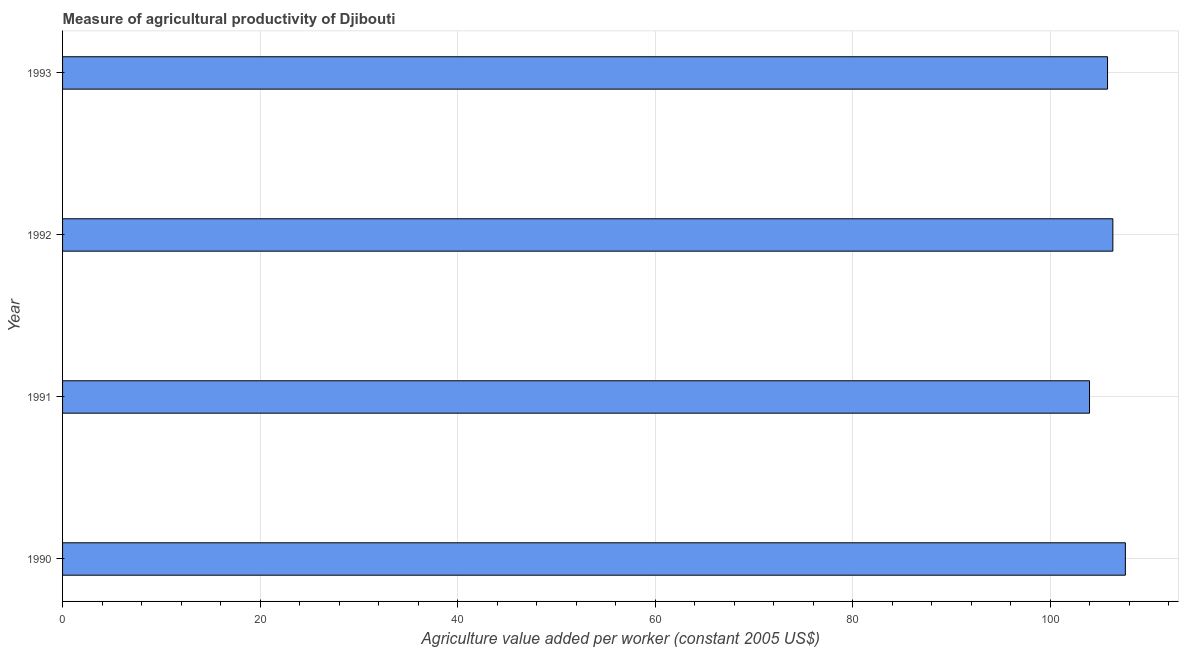Does the graph contain grids?
Your answer should be very brief. Yes. What is the title of the graph?
Offer a terse response. Measure of agricultural productivity of Djibouti. What is the label or title of the X-axis?
Provide a short and direct response. Agriculture value added per worker (constant 2005 US$). What is the label or title of the Y-axis?
Provide a short and direct response. Year. What is the agriculture value added per worker in 1990?
Your response must be concise. 107.61. Across all years, what is the maximum agriculture value added per worker?
Provide a short and direct response. 107.61. Across all years, what is the minimum agriculture value added per worker?
Provide a short and direct response. 103.98. What is the sum of the agriculture value added per worker?
Ensure brevity in your answer.  423.75. What is the difference between the agriculture value added per worker in 1990 and 1992?
Your answer should be compact. 1.26. What is the average agriculture value added per worker per year?
Your answer should be compact. 105.94. What is the median agriculture value added per worker?
Ensure brevity in your answer.  106.08. Do a majority of the years between 1991 and 1990 (inclusive) have agriculture value added per worker greater than 84 US$?
Your response must be concise. No. Is the difference between the agriculture value added per worker in 1991 and 1992 greater than the difference between any two years?
Your answer should be very brief. No. What is the difference between the highest and the second highest agriculture value added per worker?
Give a very brief answer. 1.26. What is the difference between the highest and the lowest agriculture value added per worker?
Ensure brevity in your answer.  3.63. How many bars are there?
Ensure brevity in your answer.  4. Are all the bars in the graph horizontal?
Ensure brevity in your answer.  Yes. What is the difference between two consecutive major ticks on the X-axis?
Make the answer very short. 20. Are the values on the major ticks of X-axis written in scientific E-notation?
Provide a short and direct response. No. What is the Agriculture value added per worker (constant 2005 US$) in 1990?
Make the answer very short. 107.61. What is the Agriculture value added per worker (constant 2005 US$) of 1991?
Your response must be concise. 103.98. What is the Agriculture value added per worker (constant 2005 US$) in 1992?
Provide a succinct answer. 106.35. What is the Agriculture value added per worker (constant 2005 US$) in 1993?
Your response must be concise. 105.81. What is the difference between the Agriculture value added per worker (constant 2005 US$) in 1990 and 1991?
Offer a terse response. 3.63. What is the difference between the Agriculture value added per worker (constant 2005 US$) in 1990 and 1992?
Your answer should be very brief. 1.27. What is the difference between the Agriculture value added per worker (constant 2005 US$) in 1990 and 1993?
Ensure brevity in your answer.  1.8. What is the difference between the Agriculture value added per worker (constant 2005 US$) in 1991 and 1992?
Your answer should be very brief. -2.36. What is the difference between the Agriculture value added per worker (constant 2005 US$) in 1991 and 1993?
Give a very brief answer. -1.82. What is the difference between the Agriculture value added per worker (constant 2005 US$) in 1992 and 1993?
Your response must be concise. 0.54. What is the ratio of the Agriculture value added per worker (constant 2005 US$) in 1990 to that in 1991?
Ensure brevity in your answer.  1.03. What is the ratio of the Agriculture value added per worker (constant 2005 US$) in 1990 to that in 1992?
Give a very brief answer. 1.01. What is the ratio of the Agriculture value added per worker (constant 2005 US$) in 1991 to that in 1993?
Provide a short and direct response. 0.98. 